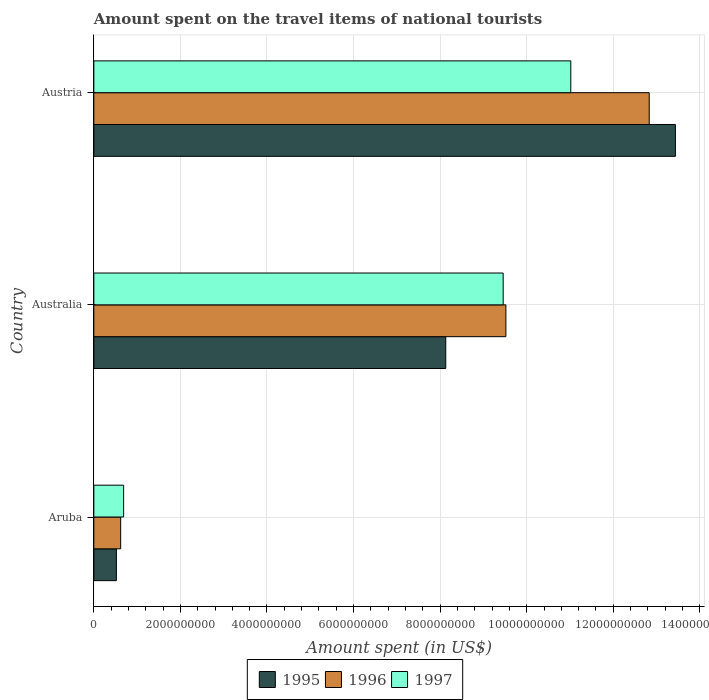How many bars are there on the 1st tick from the top?
Your response must be concise. 3. What is the amount spent on the travel items of national tourists in 1995 in Aruba?
Ensure brevity in your answer.  5.21e+08. Across all countries, what is the maximum amount spent on the travel items of national tourists in 1997?
Provide a short and direct response. 1.10e+1. Across all countries, what is the minimum amount spent on the travel items of national tourists in 1995?
Offer a very short reply. 5.21e+08. In which country was the amount spent on the travel items of national tourists in 1996 minimum?
Ensure brevity in your answer.  Aruba. What is the total amount spent on the travel items of national tourists in 1995 in the graph?
Provide a succinct answer. 2.21e+1. What is the difference between the amount spent on the travel items of national tourists in 1997 in Aruba and that in Austria?
Make the answer very short. -1.03e+1. What is the difference between the amount spent on the travel items of national tourists in 1995 in Aruba and the amount spent on the travel items of national tourists in 1996 in Australia?
Make the answer very short. -9.00e+09. What is the average amount spent on the travel items of national tourists in 1997 per country?
Give a very brief answer. 7.05e+09. What is the difference between the amount spent on the travel items of national tourists in 1996 and amount spent on the travel items of national tourists in 1995 in Aruba?
Offer a very short reply. 9.90e+07. In how many countries, is the amount spent on the travel items of national tourists in 1996 greater than 9600000000 US$?
Give a very brief answer. 1. What is the ratio of the amount spent on the travel items of national tourists in 1997 in Aruba to that in Austria?
Offer a terse response. 0.06. Is the difference between the amount spent on the travel items of national tourists in 1996 in Aruba and Australia greater than the difference between the amount spent on the travel items of national tourists in 1995 in Aruba and Australia?
Offer a terse response. No. What is the difference between the highest and the second highest amount spent on the travel items of national tourists in 1997?
Give a very brief answer. 1.56e+09. What is the difference between the highest and the lowest amount spent on the travel items of national tourists in 1997?
Your answer should be very brief. 1.03e+1. What does the 2nd bar from the top in Aruba represents?
Make the answer very short. 1996. How many bars are there?
Your answer should be very brief. 9. How many legend labels are there?
Your response must be concise. 3. What is the title of the graph?
Ensure brevity in your answer.  Amount spent on the travel items of national tourists. Does "1981" appear as one of the legend labels in the graph?
Offer a terse response. No. What is the label or title of the X-axis?
Your response must be concise. Amount spent (in US$). What is the Amount spent (in US$) in 1995 in Aruba?
Provide a short and direct response. 5.21e+08. What is the Amount spent (in US$) of 1996 in Aruba?
Your response must be concise. 6.20e+08. What is the Amount spent (in US$) of 1997 in Aruba?
Offer a very short reply. 6.89e+08. What is the Amount spent (in US$) in 1995 in Australia?
Give a very brief answer. 8.13e+09. What is the Amount spent (in US$) in 1996 in Australia?
Your response must be concise. 9.52e+09. What is the Amount spent (in US$) in 1997 in Australia?
Give a very brief answer. 9.46e+09. What is the Amount spent (in US$) of 1995 in Austria?
Provide a succinct answer. 1.34e+1. What is the Amount spent (in US$) in 1996 in Austria?
Your answer should be very brief. 1.28e+1. What is the Amount spent (in US$) of 1997 in Austria?
Make the answer very short. 1.10e+1. Across all countries, what is the maximum Amount spent (in US$) of 1995?
Make the answer very short. 1.34e+1. Across all countries, what is the maximum Amount spent (in US$) in 1996?
Ensure brevity in your answer.  1.28e+1. Across all countries, what is the maximum Amount spent (in US$) of 1997?
Provide a short and direct response. 1.10e+1. Across all countries, what is the minimum Amount spent (in US$) of 1995?
Give a very brief answer. 5.21e+08. Across all countries, what is the minimum Amount spent (in US$) in 1996?
Offer a very short reply. 6.20e+08. Across all countries, what is the minimum Amount spent (in US$) of 1997?
Your answer should be very brief. 6.89e+08. What is the total Amount spent (in US$) in 1995 in the graph?
Provide a succinct answer. 2.21e+1. What is the total Amount spent (in US$) in 1996 in the graph?
Provide a succinct answer. 2.30e+1. What is the total Amount spent (in US$) in 1997 in the graph?
Make the answer very short. 2.12e+1. What is the difference between the Amount spent (in US$) of 1995 in Aruba and that in Australia?
Ensure brevity in your answer.  -7.61e+09. What is the difference between the Amount spent (in US$) of 1996 in Aruba and that in Australia?
Offer a very short reply. -8.90e+09. What is the difference between the Amount spent (in US$) of 1997 in Aruba and that in Australia?
Give a very brief answer. -8.77e+09. What is the difference between the Amount spent (in US$) of 1995 in Aruba and that in Austria?
Make the answer very short. -1.29e+1. What is the difference between the Amount spent (in US$) in 1996 in Aruba and that in Austria?
Provide a short and direct response. -1.22e+1. What is the difference between the Amount spent (in US$) in 1997 in Aruba and that in Austria?
Your response must be concise. -1.03e+1. What is the difference between the Amount spent (in US$) in 1995 in Australia and that in Austria?
Make the answer very short. -5.30e+09. What is the difference between the Amount spent (in US$) of 1996 in Australia and that in Austria?
Ensure brevity in your answer.  -3.31e+09. What is the difference between the Amount spent (in US$) of 1997 in Australia and that in Austria?
Keep it short and to the point. -1.56e+09. What is the difference between the Amount spent (in US$) in 1995 in Aruba and the Amount spent (in US$) in 1996 in Australia?
Your response must be concise. -9.00e+09. What is the difference between the Amount spent (in US$) in 1995 in Aruba and the Amount spent (in US$) in 1997 in Australia?
Offer a terse response. -8.94e+09. What is the difference between the Amount spent (in US$) in 1996 in Aruba and the Amount spent (in US$) in 1997 in Australia?
Give a very brief answer. -8.84e+09. What is the difference between the Amount spent (in US$) in 1995 in Aruba and the Amount spent (in US$) in 1996 in Austria?
Your answer should be compact. -1.23e+1. What is the difference between the Amount spent (in US$) of 1995 in Aruba and the Amount spent (in US$) of 1997 in Austria?
Offer a very short reply. -1.05e+1. What is the difference between the Amount spent (in US$) of 1996 in Aruba and the Amount spent (in US$) of 1997 in Austria?
Ensure brevity in your answer.  -1.04e+1. What is the difference between the Amount spent (in US$) in 1995 in Australia and the Amount spent (in US$) in 1996 in Austria?
Provide a succinct answer. -4.70e+09. What is the difference between the Amount spent (in US$) of 1995 in Australia and the Amount spent (in US$) of 1997 in Austria?
Provide a short and direct response. -2.89e+09. What is the difference between the Amount spent (in US$) of 1996 in Australia and the Amount spent (in US$) of 1997 in Austria?
Your response must be concise. -1.50e+09. What is the average Amount spent (in US$) in 1995 per country?
Offer a terse response. 7.36e+09. What is the average Amount spent (in US$) of 1996 per country?
Your answer should be very brief. 7.66e+09. What is the average Amount spent (in US$) in 1997 per country?
Keep it short and to the point. 7.05e+09. What is the difference between the Amount spent (in US$) in 1995 and Amount spent (in US$) in 1996 in Aruba?
Give a very brief answer. -9.90e+07. What is the difference between the Amount spent (in US$) of 1995 and Amount spent (in US$) of 1997 in Aruba?
Your answer should be compact. -1.68e+08. What is the difference between the Amount spent (in US$) of 1996 and Amount spent (in US$) of 1997 in Aruba?
Make the answer very short. -6.90e+07. What is the difference between the Amount spent (in US$) of 1995 and Amount spent (in US$) of 1996 in Australia?
Provide a succinct answer. -1.39e+09. What is the difference between the Amount spent (in US$) in 1995 and Amount spent (in US$) in 1997 in Australia?
Your answer should be compact. -1.33e+09. What is the difference between the Amount spent (in US$) of 1996 and Amount spent (in US$) of 1997 in Australia?
Your answer should be very brief. 6.30e+07. What is the difference between the Amount spent (in US$) of 1995 and Amount spent (in US$) of 1996 in Austria?
Your answer should be very brief. 6.05e+08. What is the difference between the Amount spent (in US$) of 1995 and Amount spent (in US$) of 1997 in Austria?
Offer a very short reply. 2.42e+09. What is the difference between the Amount spent (in US$) of 1996 and Amount spent (in US$) of 1997 in Austria?
Your answer should be compact. 1.81e+09. What is the ratio of the Amount spent (in US$) in 1995 in Aruba to that in Australia?
Your answer should be very brief. 0.06. What is the ratio of the Amount spent (in US$) of 1996 in Aruba to that in Australia?
Your response must be concise. 0.07. What is the ratio of the Amount spent (in US$) of 1997 in Aruba to that in Australia?
Offer a very short reply. 0.07. What is the ratio of the Amount spent (in US$) of 1995 in Aruba to that in Austria?
Make the answer very short. 0.04. What is the ratio of the Amount spent (in US$) in 1996 in Aruba to that in Austria?
Keep it short and to the point. 0.05. What is the ratio of the Amount spent (in US$) of 1997 in Aruba to that in Austria?
Offer a terse response. 0.06. What is the ratio of the Amount spent (in US$) of 1995 in Australia to that in Austria?
Make the answer very short. 0.61. What is the ratio of the Amount spent (in US$) in 1996 in Australia to that in Austria?
Give a very brief answer. 0.74. What is the ratio of the Amount spent (in US$) of 1997 in Australia to that in Austria?
Provide a succinct answer. 0.86. What is the difference between the highest and the second highest Amount spent (in US$) in 1995?
Give a very brief answer. 5.30e+09. What is the difference between the highest and the second highest Amount spent (in US$) of 1996?
Keep it short and to the point. 3.31e+09. What is the difference between the highest and the second highest Amount spent (in US$) of 1997?
Offer a terse response. 1.56e+09. What is the difference between the highest and the lowest Amount spent (in US$) of 1995?
Offer a terse response. 1.29e+1. What is the difference between the highest and the lowest Amount spent (in US$) in 1996?
Provide a short and direct response. 1.22e+1. What is the difference between the highest and the lowest Amount spent (in US$) of 1997?
Your answer should be compact. 1.03e+1. 